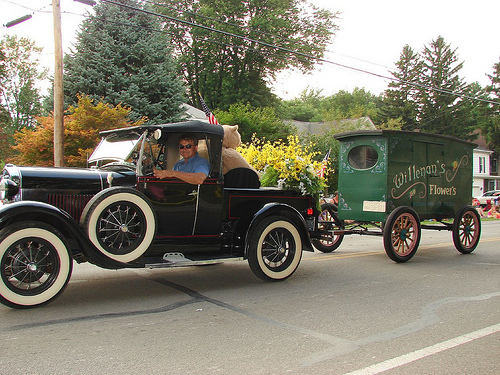<image>
Can you confirm if the car is to the left of the tree? Yes. From this viewpoint, the car is positioned to the left side relative to the tree. Where is the road in relation to the car? Is it under the car? Yes. The road is positioned underneath the car, with the car above it in the vertical space. 